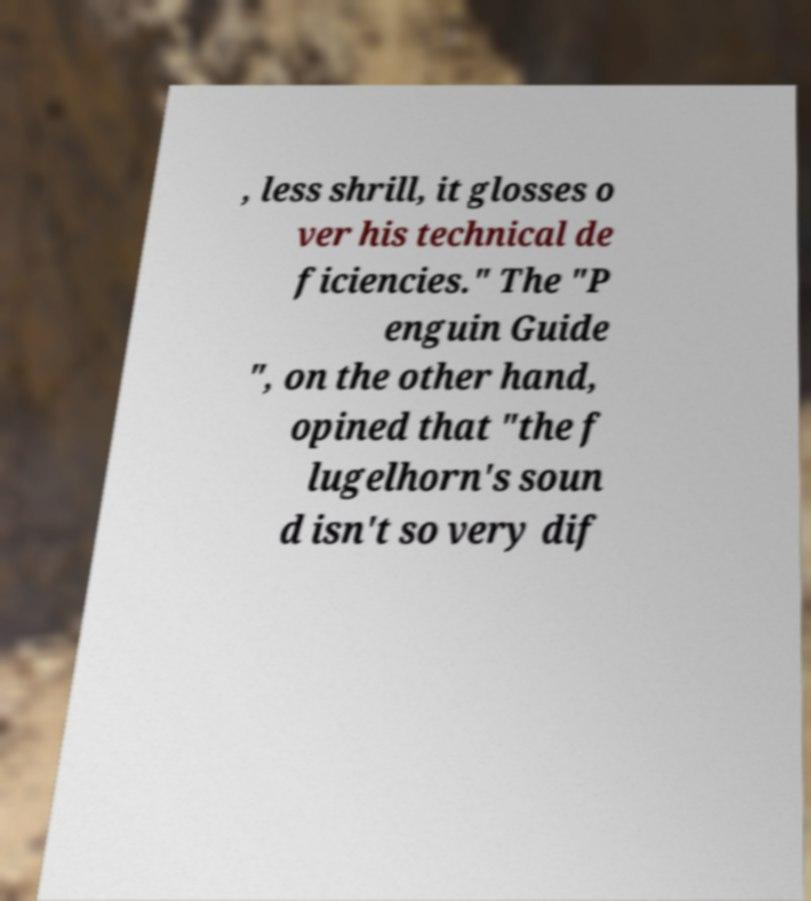What messages or text are displayed in this image? I need them in a readable, typed format. , less shrill, it glosses o ver his technical de ficiencies." The "P enguin Guide ", on the other hand, opined that "the f lugelhorn's soun d isn't so very dif 